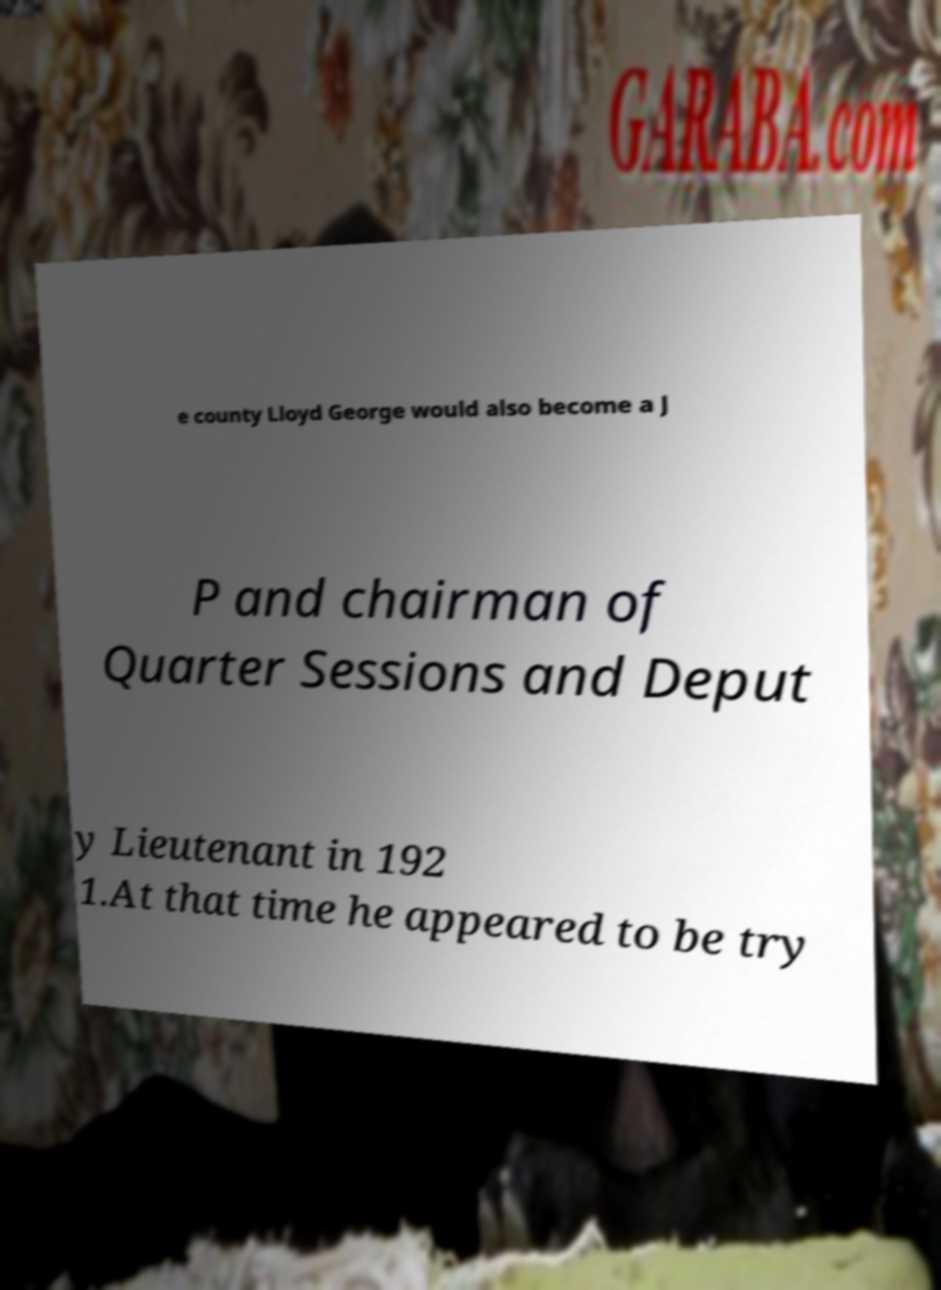Please identify and transcribe the text found in this image. e county Lloyd George would also become a J P and chairman of Quarter Sessions and Deput y Lieutenant in 192 1.At that time he appeared to be try 